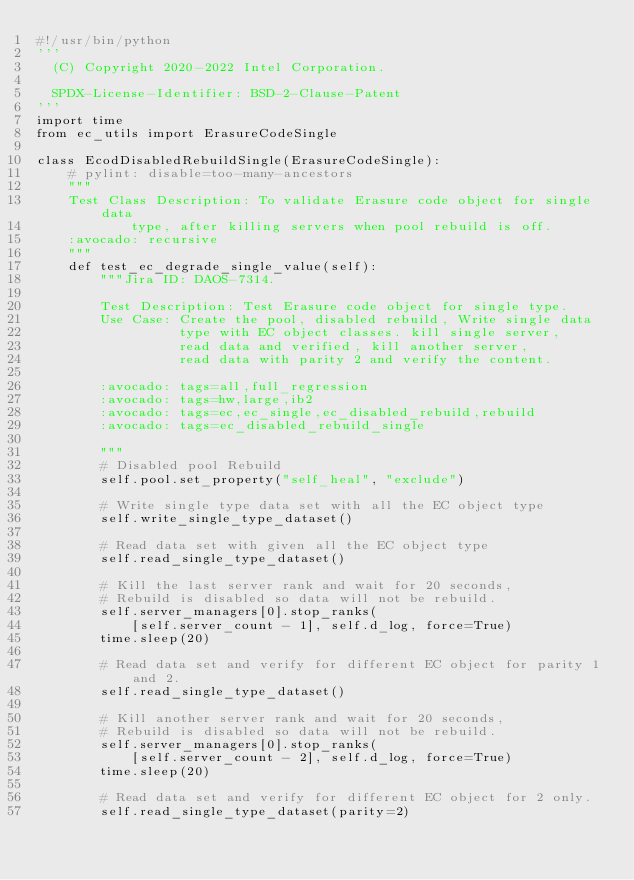Convert code to text. <code><loc_0><loc_0><loc_500><loc_500><_Python_>#!/usr/bin/python
'''
  (C) Copyright 2020-2022 Intel Corporation.

  SPDX-License-Identifier: BSD-2-Clause-Patent
'''
import time
from ec_utils import ErasureCodeSingle

class EcodDisabledRebuildSingle(ErasureCodeSingle):
    # pylint: disable=too-many-ancestors
    """
    Test Class Description: To validate Erasure code object for single data
            type, after killing servers when pool rebuild is off.
    :avocado: recursive
    """
    def test_ec_degrade_single_value(self):
        """Jira ID: DAOS-7314.

        Test Description: Test Erasure code object for single type.
        Use Case: Create the pool, disabled rebuild, Write single data
                  type with EC object classes. kill single server,
                  read data and verified, kill another server,
                  read data with parity 2 and verify the content.

        :avocado: tags=all,full_regression
        :avocado: tags=hw,large,ib2
        :avocado: tags=ec,ec_single,ec_disabled_rebuild,rebuild
        :avocado: tags=ec_disabled_rebuild_single

        """
        # Disabled pool Rebuild
        self.pool.set_property("self_heal", "exclude")

        # Write single type data set with all the EC object type
        self.write_single_type_dataset()

        # Read data set with given all the EC object type
        self.read_single_type_dataset()

        # Kill the last server rank and wait for 20 seconds,
        # Rebuild is disabled so data will not be rebuild.
        self.server_managers[0].stop_ranks(
            [self.server_count - 1], self.d_log, force=True)
        time.sleep(20)

        # Read data set and verify for different EC object for parity 1 and 2.
        self.read_single_type_dataset()

        # Kill another server rank and wait for 20 seconds,
        # Rebuild is disabled so data will not be rebuild.
        self.server_managers[0].stop_ranks(
            [self.server_count - 2], self.d_log, force=True)
        time.sleep(20)

        # Read data set and verify for different EC object for 2 only.
        self.read_single_type_dataset(parity=2)
</code> 